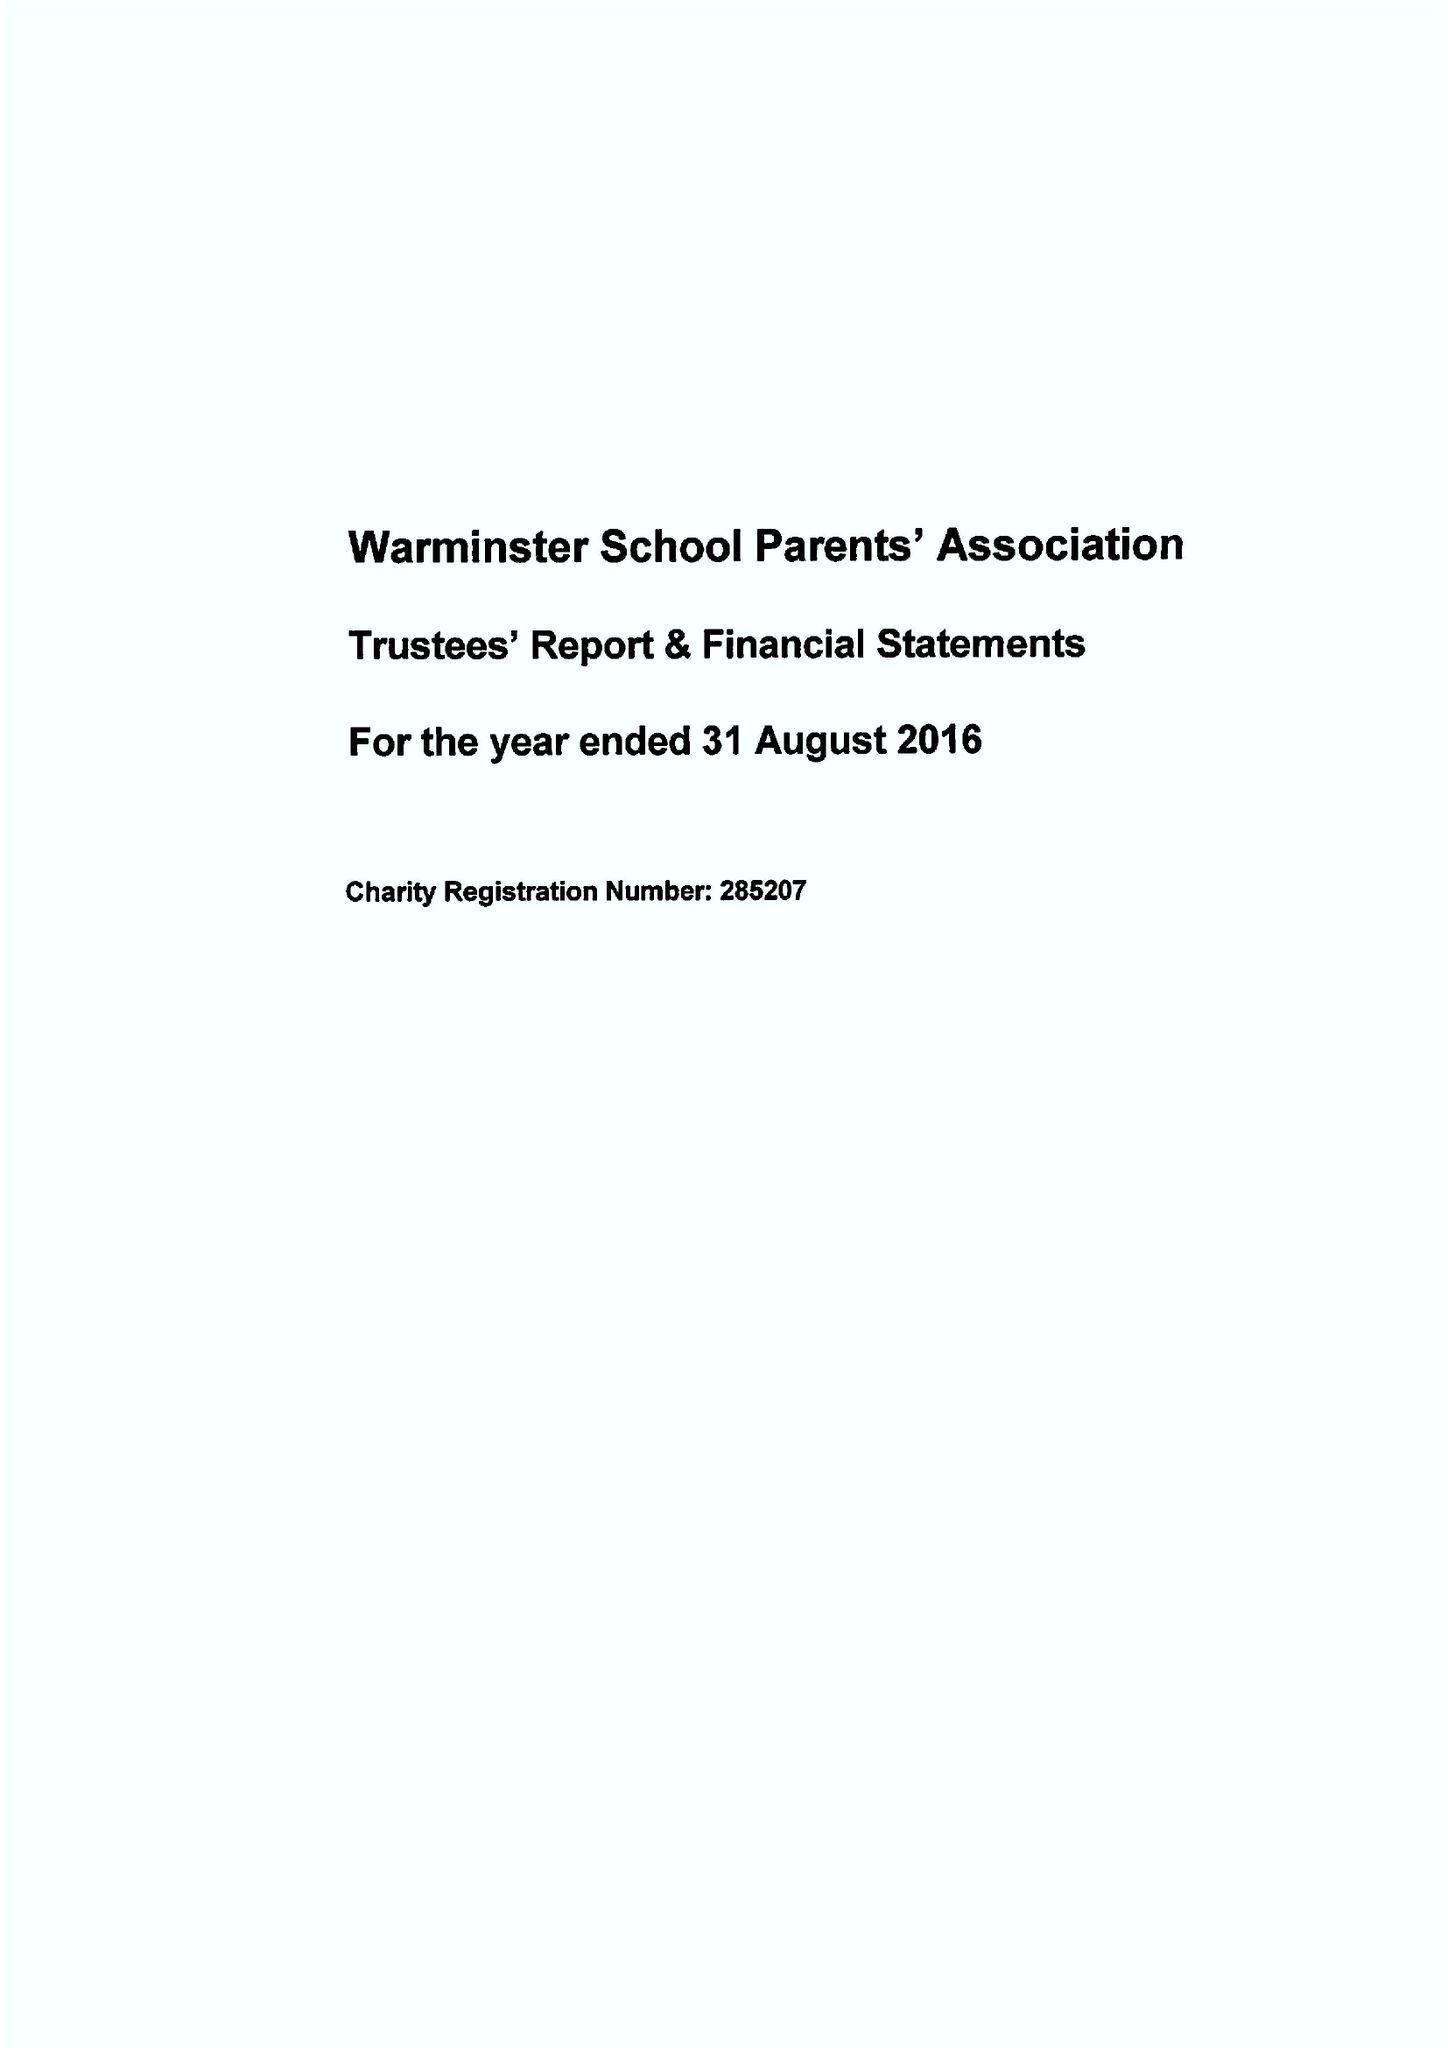What is the value for the charity_number?
Answer the question using a single word or phrase. 285207 